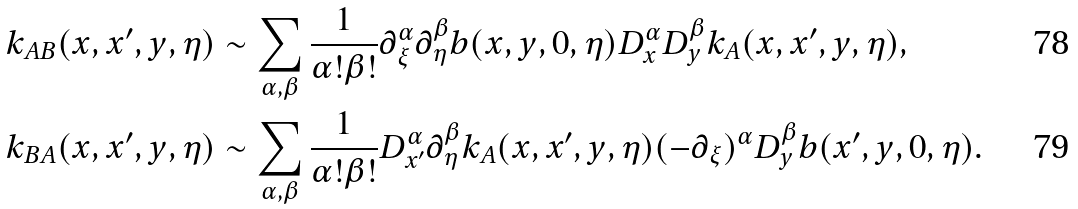Convert formula to latex. <formula><loc_0><loc_0><loc_500><loc_500>k _ { A B } ( x , x ^ { \prime } , y , \eta ) & \sim \sum _ { \alpha , \beta } \frac { 1 } { \alpha ! \beta ! } \partial _ { \xi } ^ { \alpha } \partial ^ { \beta } _ { \eta } b ( x , y , 0 , \eta ) D ^ { \alpha } _ { x } D ^ { \beta } _ { y } k _ { A } ( x , x ^ { \prime } , y , \eta ) , \\ k _ { B A } ( x , x ^ { \prime } , y , \eta ) & \sim \sum _ { \alpha , \beta } \frac { 1 } { \alpha ! \beta ! } D ^ { \alpha } _ { x ^ { \prime } } \partial ^ { \beta } _ { \eta } k _ { A } ( x , x ^ { \prime } , y , \eta ) ( - \partial _ { \xi } ) ^ { \alpha } D ^ { \beta } _ { y } b ( x ^ { \prime } , y , 0 , \eta ) .</formula> 